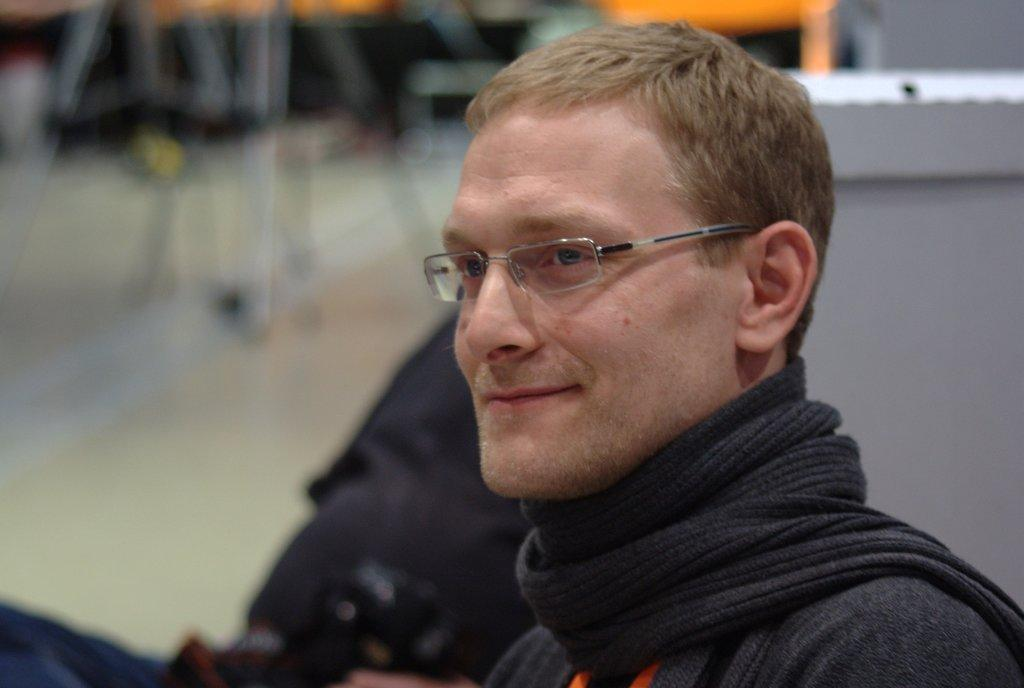What is the person in the image wearing? The person is wearing a black dress in the image. Can you describe any accessories the person is wearing? The person is wearing spectacles. Is there anyone else in the image? Yes, there is another person beside the person in the black dress. What can be seen in the background of the image? There are other objects in the background of the image. What type of cord is being used to balance the thunder in the image? There is no cord, balance, or thunder present in the image. 